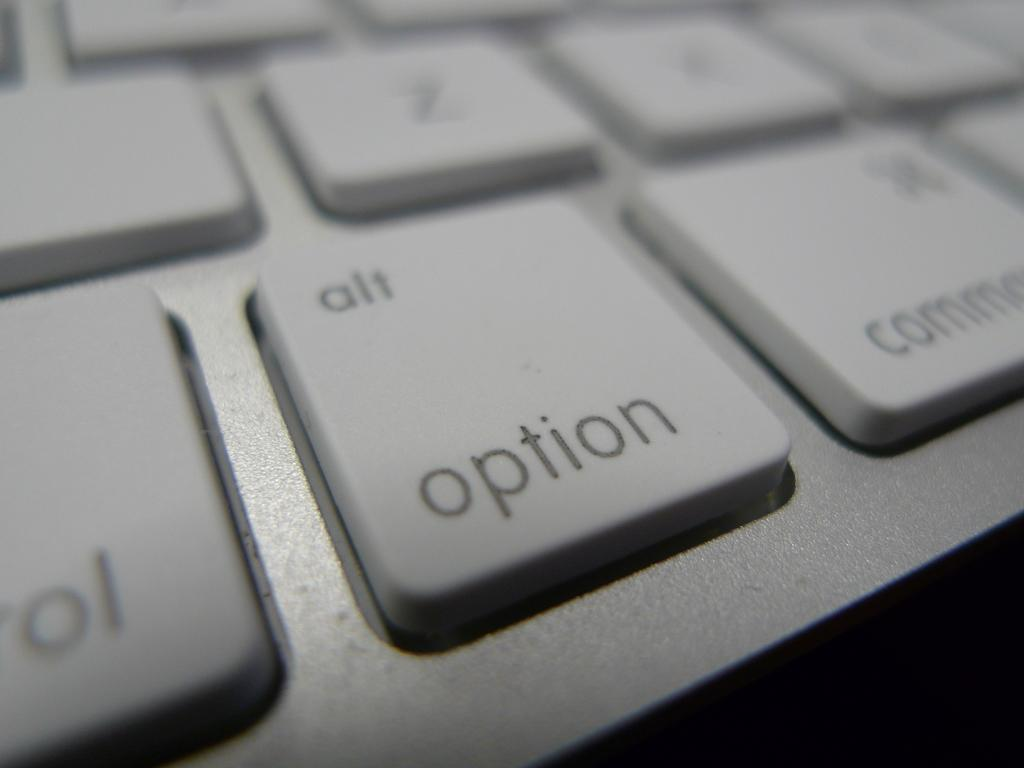<image>
Present a compact description of the photo's key features. A close up view of keys on a computer keyboard which centers the key option in the picture. 